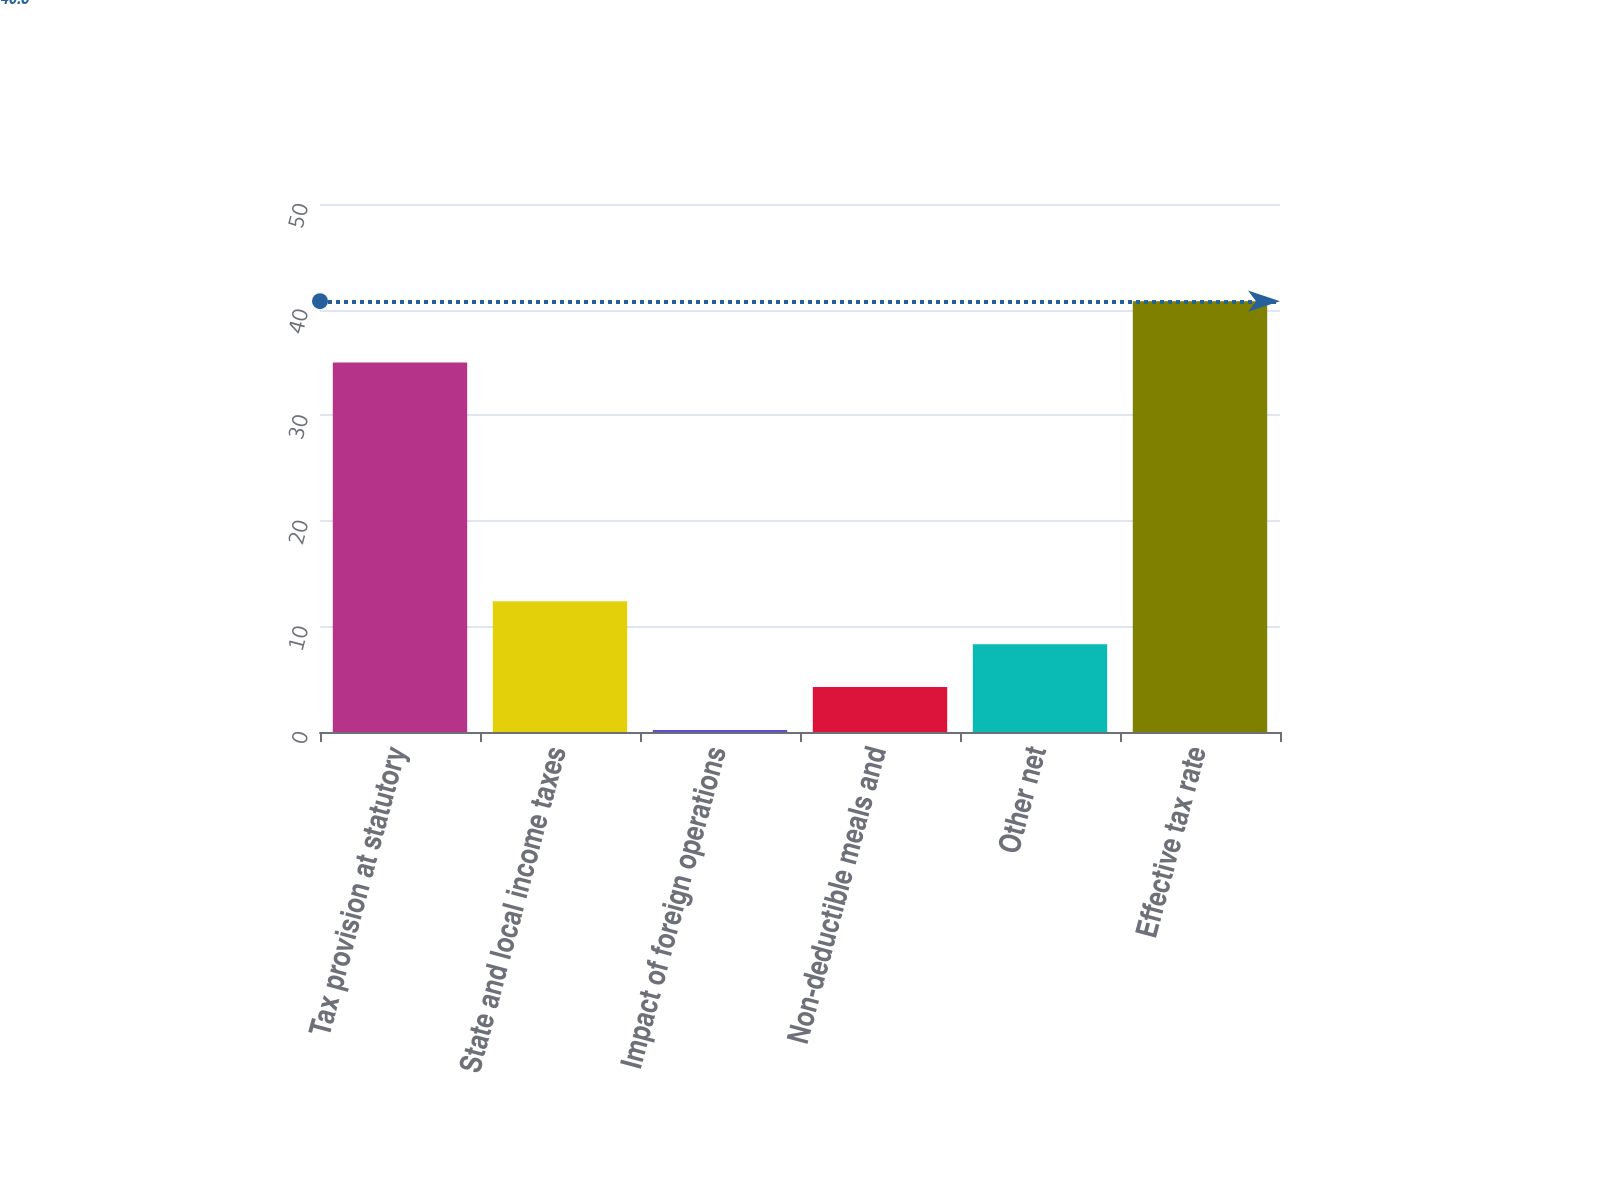Convert chart to OTSL. <chart><loc_0><loc_0><loc_500><loc_500><bar_chart><fcel>Tax provision at statutory<fcel>State and local income taxes<fcel>Impact of foreign operations<fcel>Non-deductible meals and<fcel>Other net<fcel>Effective tax rate<nl><fcel>35<fcel>12.38<fcel>0.2<fcel>4.26<fcel>8.32<fcel>40.8<nl></chart> 